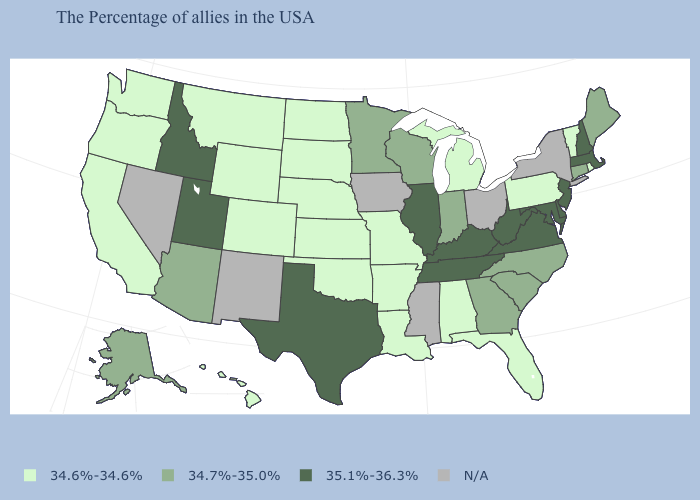What is the value of South Dakota?
Keep it brief. 34.6%-34.6%. What is the value of New Mexico?
Concise answer only. N/A. Name the states that have a value in the range 34.7%-35.0%?
Keep it brief. Maine, Connecticut, North Carolina, South Carolina, Georgia, Indiana, Wisconsin, Minnesota, Arizona, Alaska. Does New Hampshire have the highest value in the Northeast?
Short answer required. Yes. Does Connecticut have the lowest value in the USA?
Keep it brief. No. What is the highest value in states that border Arizona?
Short answer required. 35.1%-36.3%. Does Montana have the highest value in the USA?
Write a very short answer. No. Does the map have missing data?
Short answer required. Yes. Does Illinois have the highest value in the MidWest?
Write a very short answer. Yes. What is the value of West Virginia?
Answer briefly. 35.1%-36.3%. What is the value of Wyoming?
Quick response, please. 34.6%-34.6%. What is the highest value in the South ?
Short answer required. 35.1%-36.3%. How many symbols are there in the legend?
Keep it brief. 4. 